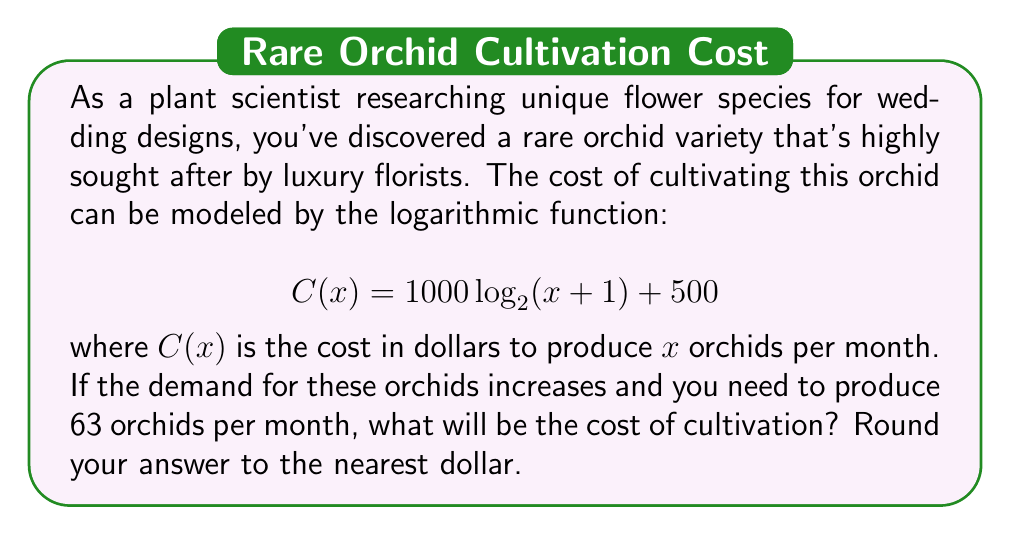Show me your answer to this math problem. To solve this problem, we need to use the given logarithmic function and substitute the value of $x$ with 63. Let's break it down step-by-step:

1. The given function is:
   $$ C(x) = 1000 \log_2(x+1) + 500 $$

2. We need to find $C(63)$, so let's substitute $x$ with 63:
   $$ C(63) = 1000 \log_2(63+1) + 500 $$
   $$ C(63) = 1000 \log_2(64) + 500 $$

3. Simplify the logarithm:
   $$ \log_2(64) = 6 $$ (since $2^6 = 64$)

4. Now our equation becomes:
   $$ C(63) = 1000 \cdot 6 + 500 $$

5. Calculate:
   $$ C(63) = 6000 + 500 = 6500 $$

Therefore, the cost of cultivating 63 orchids per month will be $6,500.
Answer: $6,500 